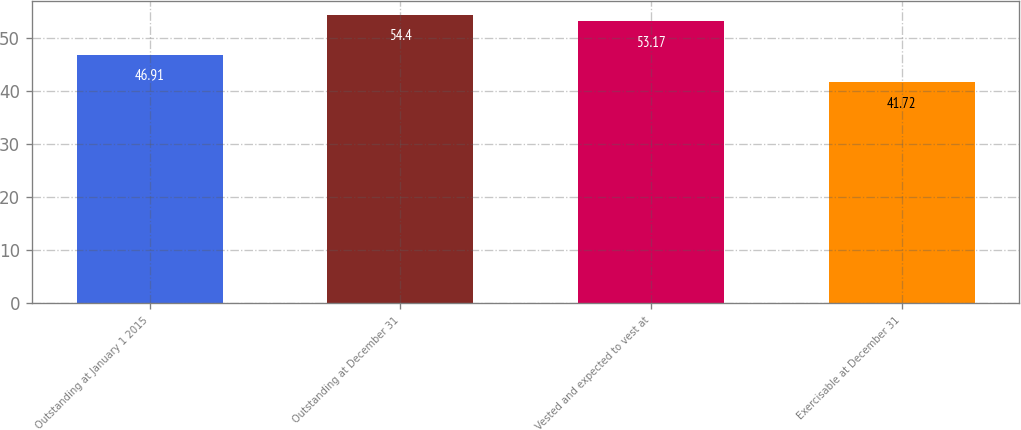<chart> <loc_0><loc_0><loc_500><loc_500><bar_chart><fcel>Outstanding at January 1 2015<fcel>Outstanding at December 31<fcel>Vested and expected to vest at<fcel>Exercisable at December 31<nl><fcel>46.91<fcel>54.4<fcel>53.17<fcel>41.72<nl></chart> 